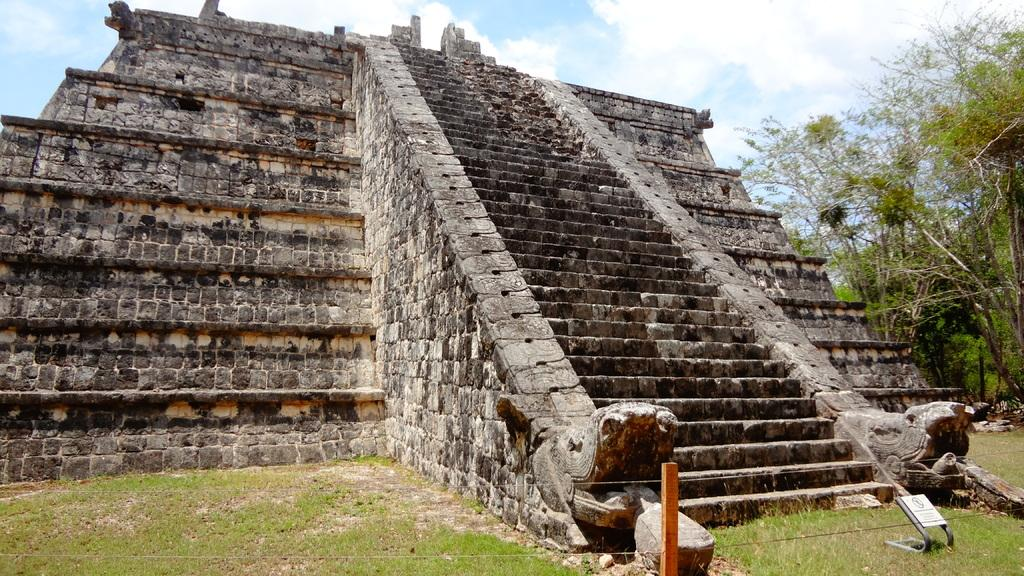What is the main structure in the image? There is a pyramid in the image. What feature can be seen in the middle of the pyramid? There are stairs in the middle of the pyramid. What type of vegetation is visible in the background of the image? There are trees in the background of the image. How would you describe the sky in the image? The sky is cloudy in the image. What type of plantation can be seen in the image? There is no plantation present in the image; it features a pyramid with stairs and a cloudy sky. How many branches are visible on the pyramid in the image? The pyramid in the image does not have branches, as it is a solid structure. 